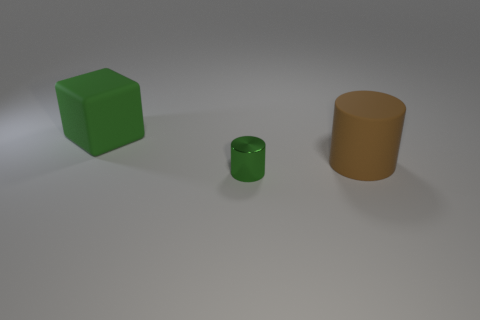Add 3 large matte objects. How many objects exist? 6 Subtract all brown cylinders. How many cylinders are left? 1 Subtract 1 cylinders. How many cylinders are left? 1 Subtract all big things. Subtract all gray shiny cubes. How many objects are left? 1 Add 1 green rubber blocks. How many green rubber blocks are left? 2 Add 2 large rubber things. How many large rubber things exist? 4 Subtract 0 gray cubes. How many objects are left? 3 Subtract all cylinders. How many objects are left? 1 